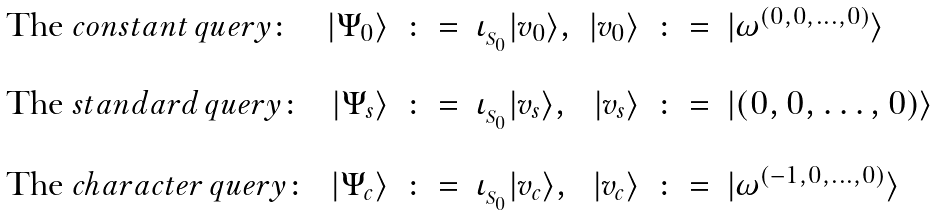<formula> <loc_0><loc_0><loc_500><loc_500>\begin{array} { l r c l r c l } \text {The } c o n s t a n t \, q u e r y \colon & | \Psi _ { 0 } \rangle & \colon = & \iota _ { _ { S _ { 0 } } } | v _ { 0 } \rangle , & | v _ { 0 } \rangle & \colon = & | \omega ^ { ( 0 , 0 , \dots , 0 ) } \rangle \\ \\ \text {The } s t a n d a r d \, q u e r y \colon & | \Psi _ { s } \rangle & \colon = & \iota _ { _ { S _ { 0 } } } | v _ { s } \rangle , & | v _ { s } \rangle & \colon = & | ( 0 , 0 , \dots , 0 ) \rangle \\ \\ \text {The } c h a r a c t e r \, q u e r y \colon & | \Psi _ { c } \rangle & \colon = & \iota _ { _ { S _ { 0 } } } | v _ { c } \rangle , & | v _ { c } \rangle & \colon = & | \omega ^ { ( - 1 , 0 , \dots , 0 ) } \rangle \end{array}</formula> 